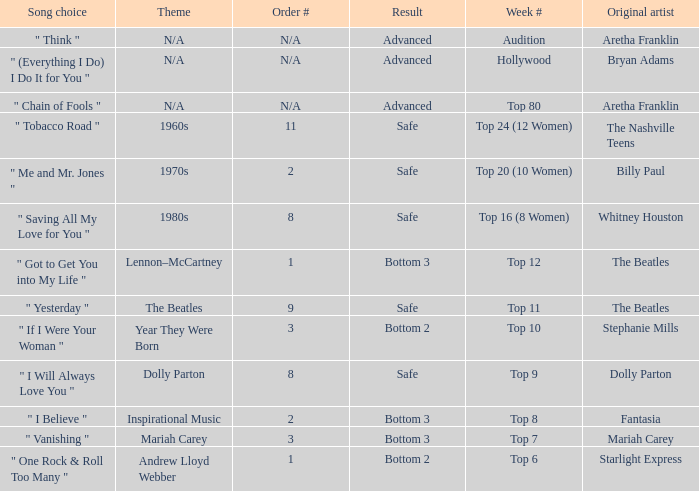Name the week number for andrew lloyd webber Top 6. Could you help me parse every detail presented in this table? {'header': ['Song choice', 'Theme', 'Order #', 'Result', 'Week #', 'Original artist'], 'rows': [['" Think "', 'N/A', 'N/A', 'Advanced', 'Audition', 'Aretha Franklin'], ['" (Everything I Do) I Do It for You "', 'N/A', 'N/A', 'Advanced', 'Hollywood', 'Bryan Adams'], ['" Chain of Fools "', 'N/A', 'N/A', 'Advanced', 'Top 80', 'Aretha Franklin'], ['" Tobacco Road "', '1960s', '11', 'Safe', 'Top 24 (12 Women)', 'The Nashville Teens'], ['" Me and Mr. Jones "', '1970s', '2', 'Safe', 'Top 20 (10 Women)', 'Billy Paul'], ['" Saving All My Love for You "', '1980s', '8', 'Safe', 'Top 16 (8 Women)', 'Whitney Houston'], ['" Got to Get You into My Life "', 'Lennon–McCartney', '1', 'Bottom 3', 'Top 12', 'The Beatles'], ['" Yesterday "', 'The Beatles', '9', 'Safe', 'Top 11', 'The Beatles'], ['" If I Were Your Woman "', 'Year They Were Born', '3', 'Bottom 2', 'Top 10', 'Stephanie Mills'], ['" I Will Always Love You "', 'Dolly Parton', '8', 'Safe', 'Top 9', 'Dolly Parton'], ['" I Believe "', 'Inspirational Music', '2', 'Bottom 3', 'Top 8', 'Fantasia'], ['" Vanishing "', 'Mariah Carey', '3', 'Bottom 3', 'Top 7', 'Mariah Carey'], ['" One Rock & Roll Too Many "', 'Andrew Lloyd Webber', '1', 'Bottom 2', 'Top 6', 'Starlight Express']]} 